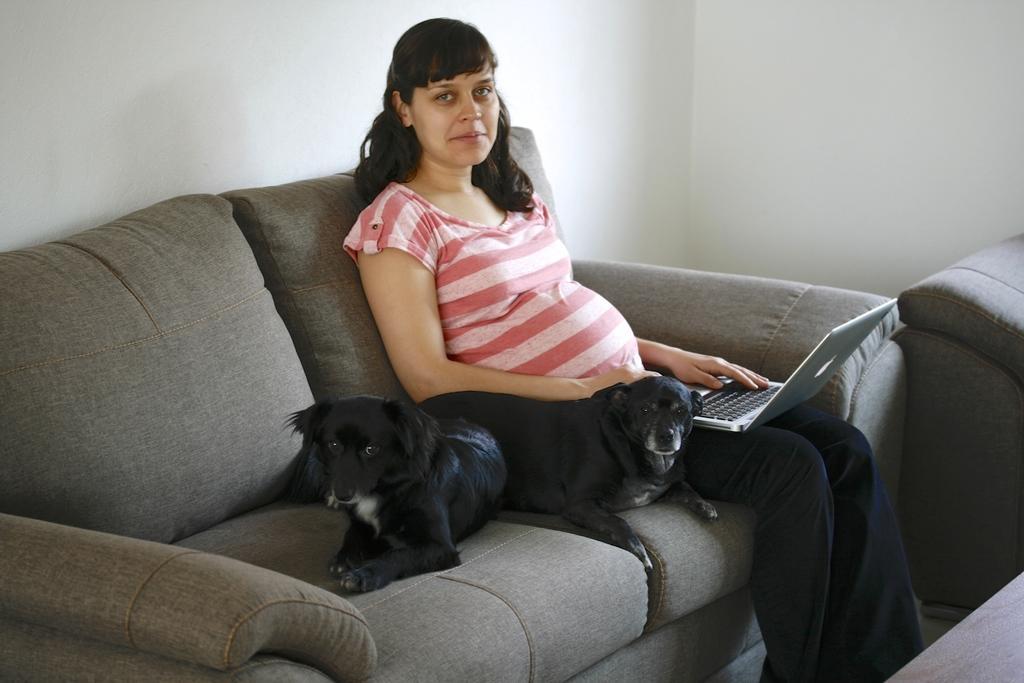Describe this image in one or two sentences. In the image we can see there is a sofa on which there are two black colour dogs are sitting and beside them there is a woman who is sitting and on her lap there is a laptop. At the back the wall is in white colour. 